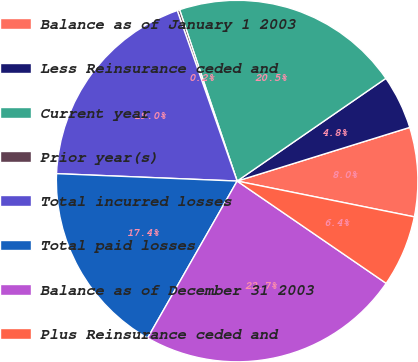<chart> <loc_0><loc_0><loc_500><loc_500><pie_chart><fcel>Balance as of January 1 2003<fcel>Less Reinsurance ceded and<fcel>Current year<fcel>Prior year(s)<fcel>Total incurred losses<fcel>Total paid losses<fcel>Balance as of December 31 2003<fcel>Plus Reinsurance ceded and<nl><fcel>7.97%<fcel>4.82%<fcel>20.54%<fcel>0.22%<fcel>18.97%<fcel>17.4%<fcel>23.68%<fcel>6.4%<nl></chart> 